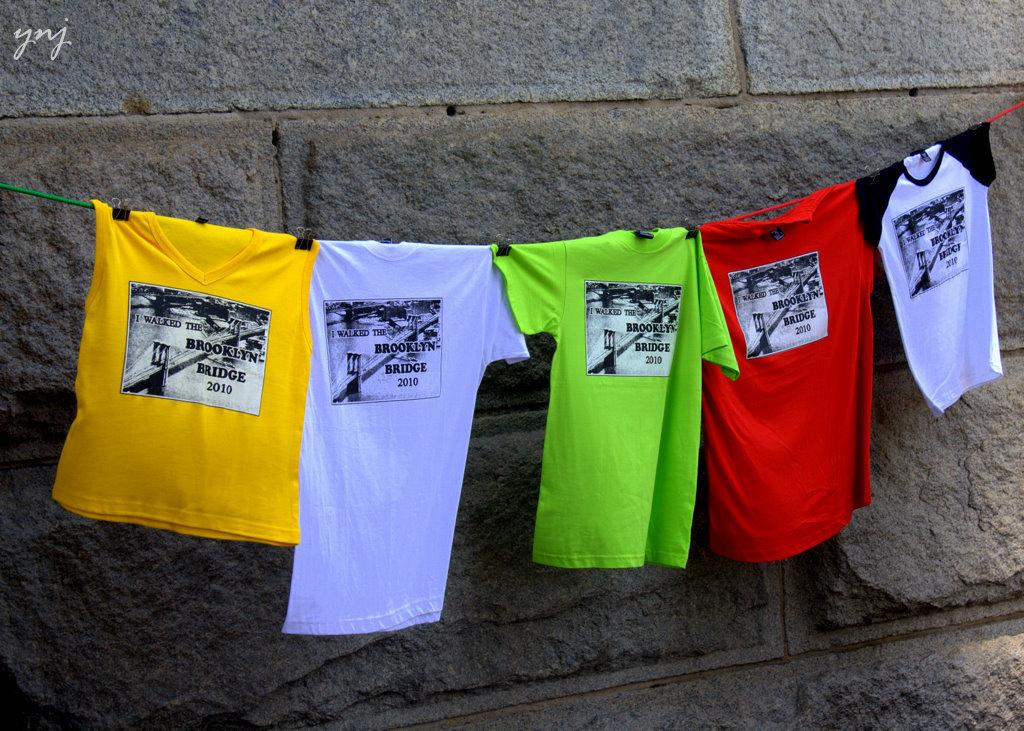Provide a one-sentence caption for the provided image. Tshirts with the words "I walked the Brooklyn Bridge" on the front of them, hanging on a clothesline in front of a building. 